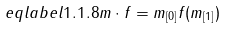Convert formula to latex. <formula><loc_0><loc_0><loc_500><loc_500>\ e q l a b e l { 1 . 1 . 8 } m \cdot f = m _ { [ 0 ] } f ( m _ { [ 1 ] } )</formula> 